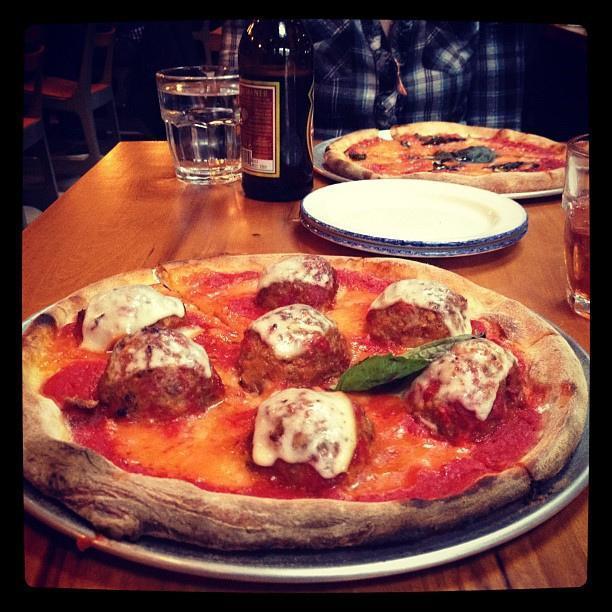The two pizzas have different sized what?
Pick the correct solution from the four options below to address the question.
Options: Plates, toppings, cheese, colors. Toppings. 